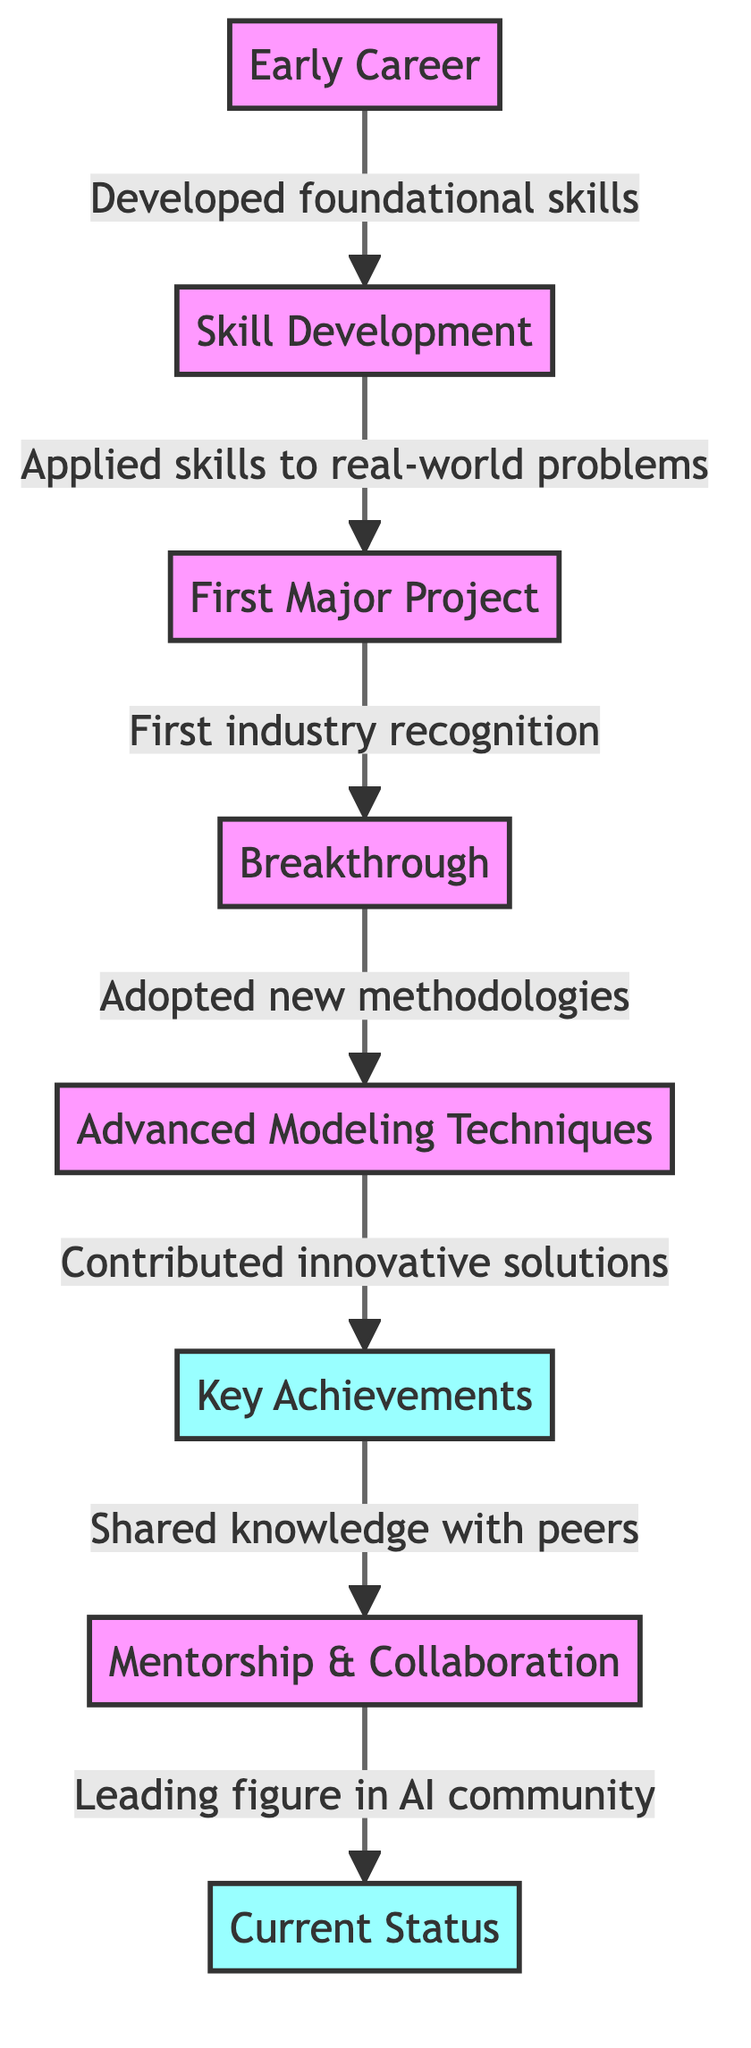What's the first node in the diagram? The first node in the diagram is labeled "Early Career." It is located at the top of the flowchart and serves as the starting point for Kaiden DuBois' career progression.
Answer: Early Career How many key achievements are listed in the diagram? The diagram includes one key achievement node that specifically highlights Kaiden DuBois’ key achievements. It is represented by a distinct node labeled "Key Achievements."
Answer: One What is the relationship between "First Major Project" and "Breakthrough"? "First Major Project" leads to "Breakthrough" as indicated by a direct arrow connecting these two nodes. The arrow signifies a progression, where the major project directly contributes to the breakthrough.
Answer: Leads to Which node represents the most current status in Kaiden DuBois' career? The node labeled "Current Status" marked with achievements is at the end of the flowchart. This indicates the latest milestones in Kaiden DuBois' journey.
Answer: Current Status What methodology was adopted after achieving the breakthrough? After the "Breakthrough," the next node is labeled "Advanced Modeling Techniques." This implies that new methodologies were adopted as a direct outcome of the breakthrough.
Answer: Advanced Modeling Techniques What is shared with peers after the key achievements? The node "Shared knowledge with peers" indicates that following the key achievements, there was an effort to impart valuable insights and experiences to colleagues or the community.
Answer: Shared knowledge with peers Which two nodes are connected to "Skill Development"? "Early Career" connects to "Skill Development," and "Skill Development" further leads to "First Major Project," indicating a direct relationship with both of these nodes.
Answer: Early Career, First Major Project What color represents the "Key Achievements" node? The "Key Achievements" node is represented in a distinct light blue color, specifically labeled with the style: "fill:#9ff." This color differentiates it from other nodes, indicating its significance.
Answer: Light blue What role does mentorship play in Kaiden DuBois' career progression? The node "Mentorship & Collaboration" follows the "Key Achievements" node and signifies that mentorship and collaboration are important factors contributing to his career growth and prominence in the AI community.
Answer: Important factor 